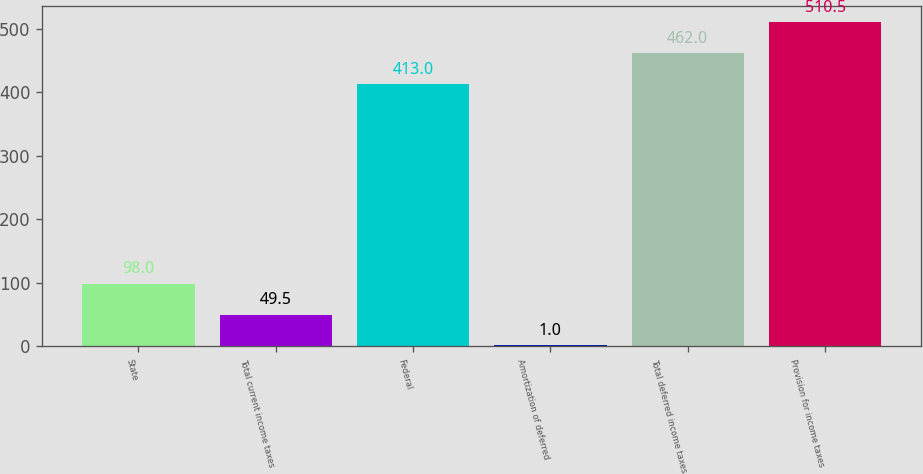Convert chart. <chart><loc_0><loc_0><loc_500><loc_500><bar_chart><fcel>State<fcel>Total current income taxes<fcel>Federal<fcel>Amortization of deferred<fcel>Total deferred income taxes<fcel>Provision for income taxes<nl><fcel>98<fcel>49.5<fcel>413<fcel>1<fcel>462<fcel>510.5<nl></chart> 